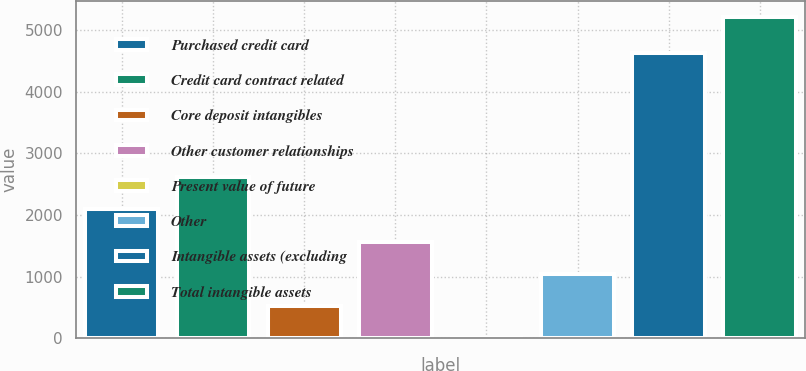<chart> <loc_0><loc_0><loc_500><loc_500><bar_chart><fcel>Purchased credit card<fcel>Credit card contract related<fcel>Core deposit intangibles<fcel>Other customer relationships<fcel>Present value of future<fcel>Other<fcel>Intangible assets (excluding<fcel>Total intangible assets<nl><fcel>2089.8<fcel>2611.5<fcel>524.7<fcel>1568.1<fcel>3<fcel>1046.4<fcel>4636<fcel>5220<nl></chart> 